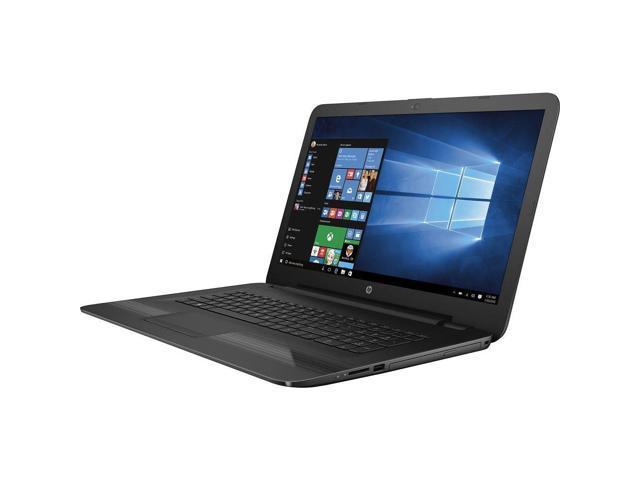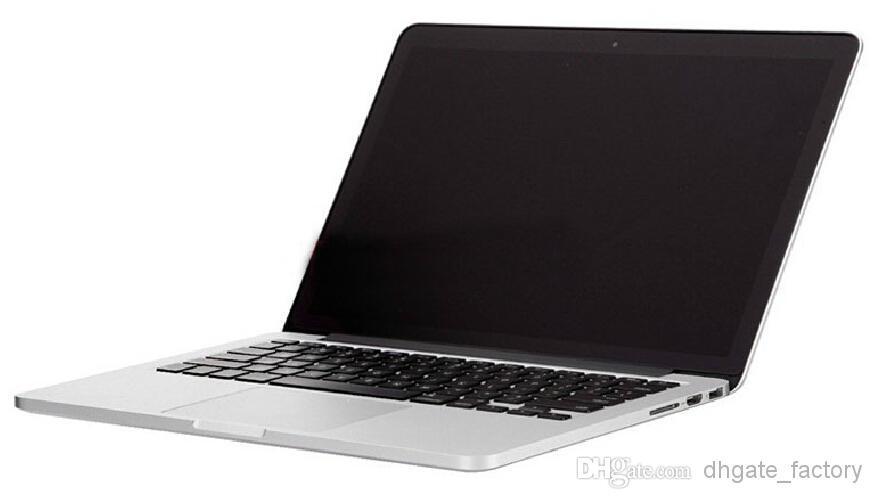The first image is the image on the left, the second image is the image on the right. Evaluate the accuracy of this statement regarding the images: "The laptop in the image on the left is facing right.". Is it true? Answer yes or no. No. 